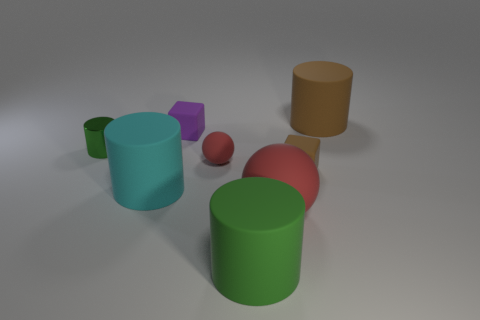Is there any other thing that has the same material as the tiny green cylinder?
Offer a terse response. No. Are there the same number of matte objects that are behind the small brown block and matte balls in front of the purple object?
Provide a succinct answer. No. What material is the brown object that is the same shape as the green metal thing?
Make the answer very short. Rubber. There is a brown rubber object in front of the brown thing behind the rubber cube to the right of the large rubber ball; what shape is it?
Provide a succinct answer. Cube. Is the number of cylinders that are in front of the cyan cylinder greater than the number of big brown metallic cylinders?
Your answer should be compact. Yes. Does the brown rubber object in front of the big brown matte thing have the same shape as the tiny purple object?
Ensure brevity in your answer.  Yes. There is a tiny thing that is to the left of the tiny purple rubber object; what material is it?
Offer a terse response. Metal. How many brown things are the same shape as the tiny green shiny object?
Offer a very short reply. 1. What material is the small cube that is behind the brown object that is in front of the brown rubber cylinder?
Your response must be concise. Rubber. What is the shape of the rubber object that is the same color as the metallic object?
Offer a terse response. Cylinder. 